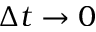Convert formula to latex. <formula><loc_0><loc_0><loc_500><loc_500>\Delta t \rightarrow 0</formula> 